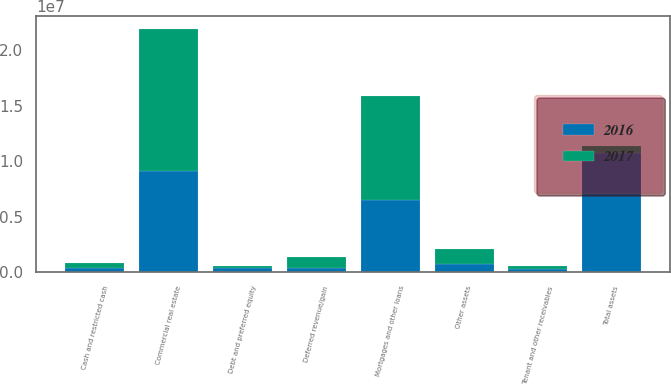<chart> <loc_0><loc_0><loc_500><loc_500><stacked_bar_chart><ecel><fcel>Commercial real estate<fcel>Cash and restricted cash<fcel>Tenant and other receivables<fcel>Debt and preferred equity<fcel>Other assets<fcel>Total assets<fcel>Mortgages and other loans<fcel>Deferred revenue/gain<nl><fcel>2017<fcel>1.28221e+07<fcel>494909<fcel>349944<fcel>202539<fcel>1.40781e+06<fcel>683481<fcel>9.4121e+06<fcel>985648<nl><fcel>2016<fcel>9.13172e+06<fcel>328455<fcel>232778<fcel>336164<fcel>683481<fcel>1.07126e+07<fcel>6.45397e+06<fcel>356414<nl></chart> 